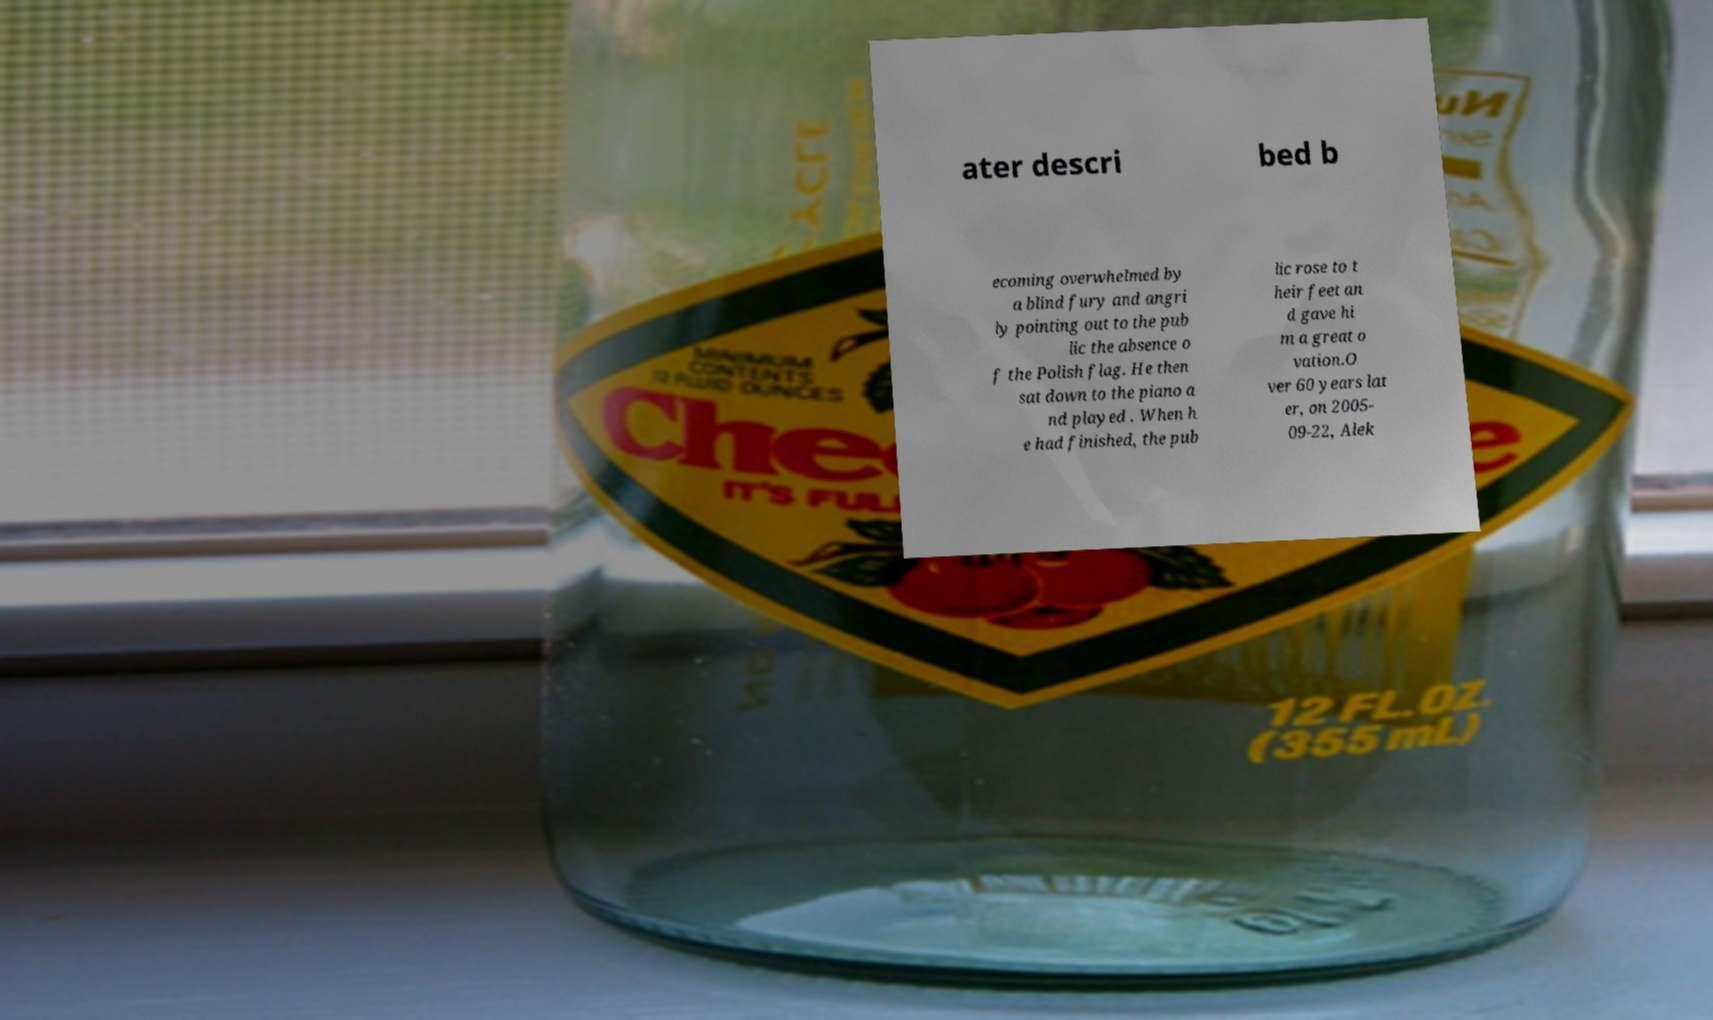Could you assist in decoding the text presented in this image and type it out clearly? ater descri bed b ecoming overwhelmed by a blind fury and angri ly pointing out to the pub lic the absence o f the Polish flag. He then sat down to the piano a nd played . When h e had finished, the pub lic rose to t heir feet an d gave hi m a great o vation.O ver 60 years lat er, on 2005- 09-22, Alek 